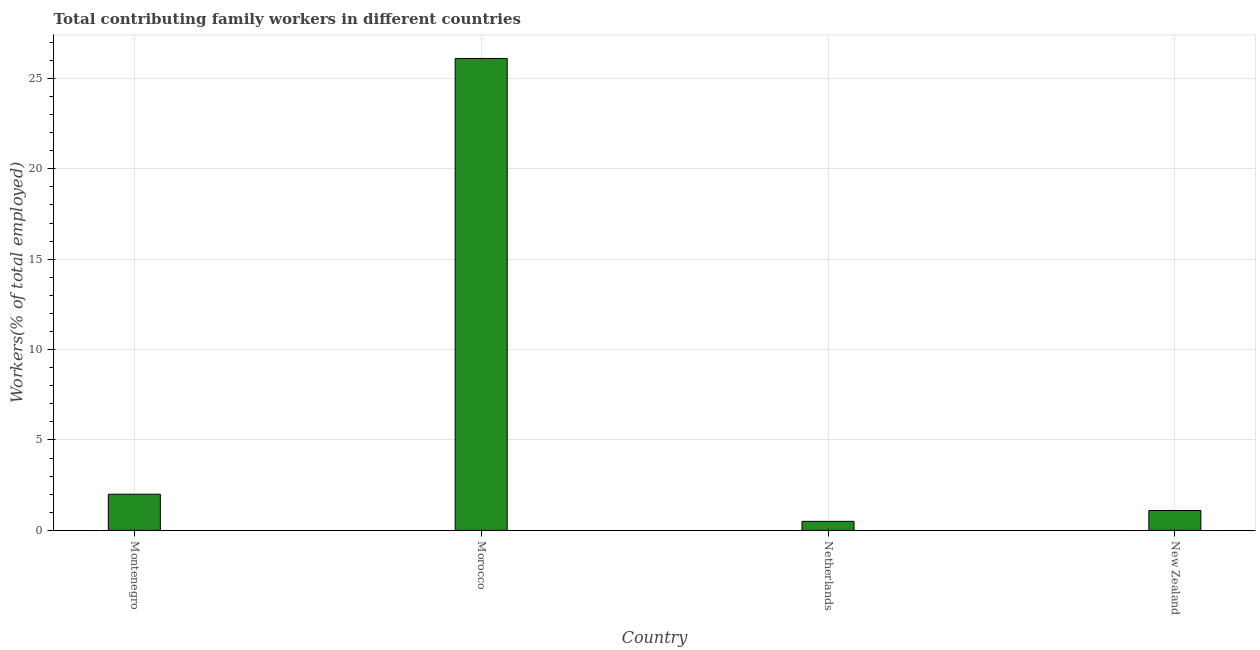What is the title of the graph?
Make the answer very short. Total contributing family workers in different countries. What is the label or title of the Y-axis?
Ensure brevity in your answer.  Workers(% of total employed). Across all countries, what is the maximum contributing family workers?
Offer a terse response. 26.1. Across all countries, what is the minimum contributing family workers?
Ensure brevity in your answer.  0.5. In which country was the contributing family workers maximum?
Your response must be concise. Morocco. What is the sum of the contributing family workers?
Offer a very short reply. 29.7. What is the average contributing family workers per country?
Offer a terse response. 7.42. What is the median contributing family workers?
Your answer should be very brief. 1.55. What is the ratio of the contributing family workers in Netherlands to that in New Zealand?
Your response must be concise. 0.46. What is the difference between the highest and the second highest contributing family workers?
Your response must be concise. 24.1. Is the sum of the contributing family workers in Netherlands and New Zealand greater than the maximum contributing family workers across all countries?
Ensure brevity in your answer.  No. What is the difference between the highest and the lowest contributing family workers?
Keep it short and to the point. 25.6. What is the difference between two consecutive major ticks on the Y-axis?
Ensure brevity in your answer.  5. What is the Workers(% of total employed) of Morocco?
Offer a terse response. 26.1. What is the Workers(% of total employed) of New Zealand?
Offer a terse response. 1.1. What is the difference between the Workers(% of total employed) in Montenegro and Morocco?
Provide a short and direct response. -24.1. What is the difference between the Workers(% of total employed) in Montenegro and New Zealand?
Your answer should be very brief. 0.9. What is the difference between the Workers(% of total employed) in Morocco and Netherlands?
Provide a succinct answer. 25.6. What is the ratio of the Workers(% of total employed) in Montenegro to that in Morocco?
Keep it short and to the point. 0.08. What is the ratio of the Workers(% of total employed) in Montenegro to that in New Zealand?
Your response must be concise. 1.82. What is the ratio of the Workers(% of total employed) in Morocco to that in Netherlands?
Provide a succinct answer. 52.2. What is the ratio of the Workers(% of total employed) in Morocco to that in New Zealand?
Your answer should be very brief. 23.73. What is the ratio of the Workers(% of total employed) in Netherlands to that in New Zealand?
Give a very brief answer. 0.46. 